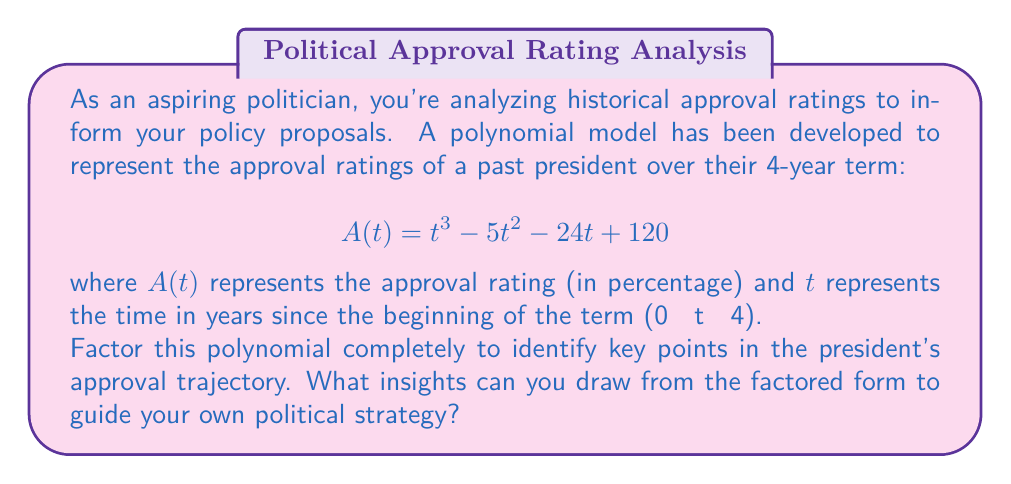Could you help me with this problem? To factor this polynomial, we'll follow these steps:

1) First, let's check if there are any rational roots using the rational root theorem. The possible rational roots are the factors of the constant term: ±1, ±2, ±3, ±4, ±5, ±6, ±8, ±10, ±12, ±15, ±20, ±24, ±30, ±40, ±60, ±120.

2) Testing these values, we find that $t = 3$ and $t = 5$ are roots of the polynomial.

3) We can factor out $(t - 3)$:

   $A(t) = (t - 3)(t^2 + at + b)$

4) Expanding this and comparing coefficients with the original polynomial, we can determine $a$ and $b$:

   $t^3 + at^2 + bt - 3t^2 - 3at - 3b = t^3 - 5t^2 - 24t + 120$

   This gives us: $a = -2$, $b = 40$

5) So now we have:

   $A(t) = (t - 3)(t^2 - 2t + 40)$

6) We know that 5 is also a root, so $(t - 5)$ must be a factor of $(t^2 - 2t + 40)$

7) Factoring further:

   $A(t) = (t - 3)(t - 5)(t + 3)$

Therefore, the fully factored form is:

$$A(t) = (t - 3)(t - 5)(t + 3)$$

Political insights:
1) The approval rating is zero when $t = 3$ and $t = 5$. This suggests the president faced significant challenges in their 3rd year and beyond their term.
2) There's a positive factor $(t + 3)$, indicating a potential for high approval early in the term.
3) The polynomial changes sign twice, suggesting the approval rating curve crosses the 50% mark twice during the term.
Answer: $$A(t) = (t - 3)(t - 5)(t + 3)$$ 